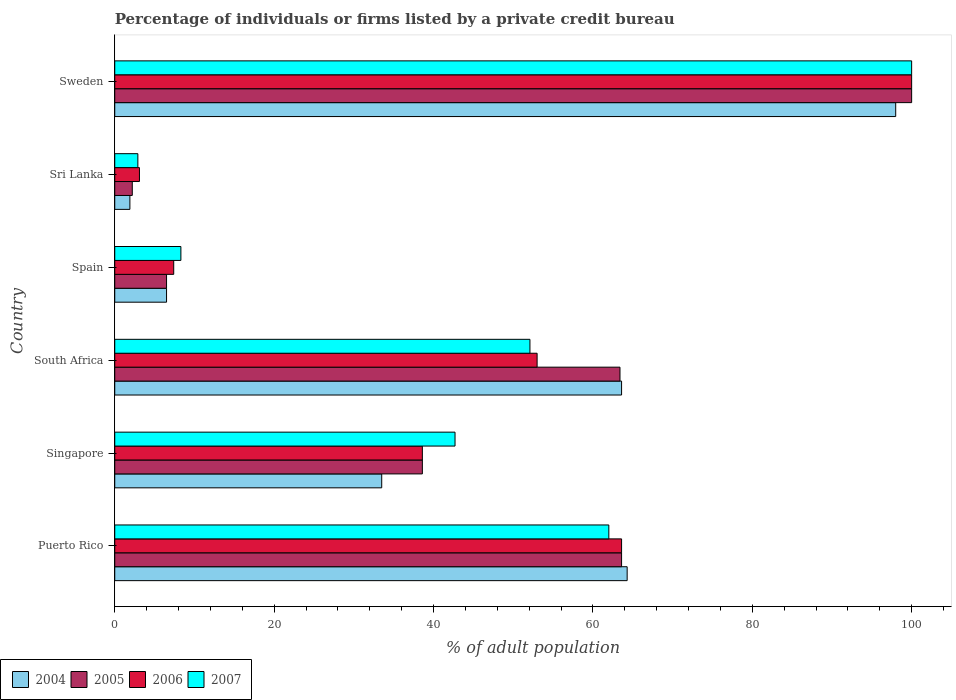Are the number of bars per tick equal to the number of legend labels?
Keep it short and to the point. Yes. Are the number of bars on each tick of the Y-axis equal?
Provide a short and direct response. Yes. What is the label of the 6th group of bars from the top?
Provide a short and direct response. Puerto Rico. In how many cases, is the number of bars for a given country not equal to the number of legend labels?
Ensure brevity in your answer.  0. What is the percentage of population listed by a private credit bureau in 2004 in Spain?
Your answer should be very brief. 6.5. Across all countries, what is the maximum percentage of population listed by a private credit bureau in 2004?
Your response must be concise. 98. Across all countries, what is the minimum percentage of population listed by a private credit bureau in 2007?
Provide a succinct answer. 2.9. In which country was the percentage of population listed by a private credit bureau in 2007 maximum?
Your response must be concise. Sweden. In which country was the percentage of population listed by a private credit bureau in 2004 minimum?
Provide a succinct answer. Sri Lanka. What is the total percentage of population listed by a private credit bureau in 2005 in the graph?
Make the answer very short. 274.3. What is the difference between the percentage of population listed by a private credit bureau in 2005 in South Africa and that in Sweden?
Your response must be concise. -36.6. What is the difference between the percentage of population listed by a private credit bureau in 2004 in Sweden and the percentage of population listed by a private credit bureau in 2006 in Spain?
Provide a succinct answer. 90.6. What is the average percentage of population listed by a private credit bureau in 2006 per country?
Keep it short and to the point. 44.28. What is the difference between the percentage of population listed by a private credit bureau in 2004 and percentage of population listed by a private credit bureau in 2006 in Singapore?
Give a very brief answer. -5.1. What is the ratio of the percentage of population listed by a private credit bureau in 2004 in South Africa to that in Sri Lanka?
Your answer should be compact. 33.47. What is the difference between the highest and the second highest percentage of population listed by a private credit bureau in 2006?
Make the answer very short. 36.4. What is the difference between the highest and the lowest percentage of population listed by a private credit bureau in 2004?
Ensure brevity in your answer.  96.1. In how many countries, is the percentage of population listed by a private credit bureau in 2005 greater than the average percentage of population listed by a private credit bureau in 2005 taken over all countries?
Make the answer very short. 3. Is the sum of the percentage of population listed by a private credit bureau in 2005 in Singapore and Sri Lanka greater than the maximum percentage of population listed by a private credit bureau in 2004 across all countries?
Make the answer very short. No. Is it the case that in every country, the sum of the percentage of population listed by a private credit bureau in 2006 and percentage of population listed by a private credit bureau in 2007 is greater than the sum of percentage of population listed by a private credit bureau in 2004 and percentage of population listed by a private credit bureau in 2005?
Your response must be concise. No. What does the 2nd bar from the top in Sri Lanka represents?
Give a very brief answer. 2006. How many bars are there?
Your answer should be compact. 24. Are all the bars in the graph horizontal?
Your response must be concise. Yes. Are the values on the major ticks of X-axis written in scientific E-notation?
Provide a short and direct response. No. Does the graph contain grids?
Keep it short and to the point. No. Where does the legend appear in the graph?
Offer a very short reply. Bottom left. How many legend labels are there?
Provide a short and direct response. 4. How are the legend labels stacked?
Provide a short and direct response. Horizontal. What is the title of the graph?
Provide a short and direct response. Percentage of individuals or firms listed by a private credit bureau. What is the label or title of the X-axis?
Offer a terse response. % of adult population. What is the label or title of the Y-axis?
Keep it short and to the point. Country. What is the % of adult population in 2004 in Puerto Rico?
Provide a succinct answer. 64.3. What is the % of adult population in 2005 in Puerto Rico?
Your answer should be very brief. 63.6. What is the % of adult population in 2006 in Puerto Rico?
Your response must be concise. 63.6. What is the % of adult population in 2007 in Puerto Rico?
Provide a succinct answer. 62. What is the % of adult population of 2004 in Singapore?
Ensure brevity in your answer.  33.5. What is the % of adult population in 2005 in Singapore?
Your answer should be compact. 38.6. What is the % of adult population of 2006 in Singapore?
Make the answer very short. 38.6. What is the % of adult population in 2007 in Singapore?
Ensure brevity in your answer.  42.7. What is the % of adult population of 2004 in South Africa?
Your answer should be very brief. 63.6. What is the % of adult population in 2005 in South Africa?
Offer a very short reply. 63.4. What is the % of adult population of 2006 in South Africa?
Offer a very short reply. 53. What is the % of adult population in 2007 in South Africa?
Offer a terse response. 52.1. What is the % of adult population in 2004 in Spain?
Make the answer very short. 6.5. What is the % of adult population in 2005 in Spain?
Your answer should be compact. 6.5. What is the % of adult population in 2007 in Spain?
Provide a succinct answer. 8.3. What is the % of adult population of 2004 in Sri Lanka?
Make the answer very short. 1.9. What is the % of adult population of 2006 in Sri Lanka?
Your response must be concise. 3.1. What is the % of adult population in 2007 in Sri Lanka?
Your answer should be compact. 2.9. What is the % of adult population of 2005 in Sweden?
Provide a short and direct response. 100. What is the % of adult population in 2006 in Sweden?
Give a very brief answer. 100. Across all countries, what is the maximum % of adult population in 2005?
Provide a succinct answer. 100. Across all countries, what is the maximum % of adult population of 2006?
Offer a very short reply. 100. Across all countries, what is the maximum % of adult population of 2007?
Provide a short and direct response. 100. Across all countries, what is the minimum % of adult population of 2004?
Your answer should be compact. 1.9. What is the total % of adult population in 2004 in the graph?
Keep it short and to the point. 267.8. What is the total % of adult population of 2005 in the graph?
Give a very brief answer. 274.3. What is the total % of adult population of 2006 in the graph?
Your answer should be very brief. 265.7. What is the total % of adult population in 2007 in the graph?
Your response must be concise. 268. What is the difference between the % of adult population of 2004 in Puerto Rico and that in Singapore?
Give a very brief answer. 30.8. What is the difference between the % of adult population of 2007 in Puerto Rico and that in Singapore?
Provide a succinct answer. 19.3. What is the difference between the % of adult population of 2004 in Puerto Rico and that in South Africa?
Provide a short and direct response. 0.7. What is the difference between the % of adult population in 2005 in Puerto Rico and that in South Africa?
Your response must be concise. 0.2. What is the difference between the % of adult population of 2006 in Puerto Rico and that in South Africa?
Provide a short and direct response. 10.6. What is the difference between the % of adult population in 2004 in Puerto Rico and that in Spain?
Ensure brevity in your answer.  57.8. What is the difference between the % of adult population of 2005 in Puerto Rico and that in Spain?
Make the answer very short. 57.1. What is the difference between the % of adult population of 2006 in Puerto Rico and that in Spain?
Provide a short and direct response. 56.2. What is the difference between the % of adult population of 2007 in Puerto Rico and that in Spain?
Give a very brief answer. 53.7. What is the difference between the % of adult population in 2004 in Puerto Rico and that in Sri Lanka?
Ensure brevity in your answer.  62.4. What is the difference between the % of adult population in 2005 in Puerto Rico and that in Sri Lanka?
Your response must be concise. 61.4. What is the difference between the % of adult population in 2006 in Puerto Rico and that in Sri Lanka?
Give a very brief answer. 60.5. What is the difference between the % of adult population in 2007 in Puerto Rico and that in Sri Lanka?
Provide a succinct answer. 59.1. What is the difference between the % of adult population in 2004 in Puerto Rico and that in Sweden?
Keep it short and to the point. -33.7. What is the difference between the % of adult population in 2005 in Puerto Rico and that in Sweden?
Keep it short and to the point. -36.4. What is the difference between the % of adult population of 2006 in Puerto Rico and that in Sweden?
Give a very brief answer. -36.4. What is the difference between the % of adult population of 2007 in Puerto Rico and that in Sweden?
Make the answer very short. -38. What is the difference between the % of adult population of 2004 in Singapore and that in South Africa?
Make the answer very short. -30.1. What is the difference between the % of adult population in 2005 in Singapore and that in South Africa?
Offer a very short reply. -24.8. What is the difference between the % of adult population in 2006 in Singapore and that in South Africa?
Your answer should be very brief. -14.4. What is the difference between the % of adult population in 2007 in Singapore and that in South Africa?
Give a very brief answer. -9.4. What is the difference between the % of adult population in 2005 in Singapore and that in Spain?
Your answer should be very brief. 32.1. What is the difference between the % of adult population in 2006 in Singapore and that in Spain?
Your response must be concise. 31.2. What is the difference between the % of adult population in 2007 in Singapore and that in Spain?
Offer a terse response. 34.4. What is the difference between the % of adult population in 2004 in Singapore and that in Sri Lanka?
Give a very brief answer. 31.6. What is the difference between the % of adult population of 2005 in Singapore and that in Sri Lanka?
Your answer should be very brief. 36.4. What is the difference between the % of adult population of 2006 in Singapore and that in Sri Lanka?
Provide a short and direct response. 35.5. What is the difference between the % of adult population of 2007 in Singapore and that in Sri Lanka?
Your response must be concise. 39.8. What is the difference between the % of adult population of 2004 in Singapore and that in Sweden?
Give a very brief answer. -64.5. What is the difference between the % of adult population of 2005 in Singapore and that in Sweden?
Provide a short and direct response. -61.4. What is the difference between the % of adult population in 2006 in Singapore and that in Sweden?
Your answer should be compact. -61.4. What is the difference between the % of adult population in 2007 in Singapore and that in Sweden?
Your answer should be compact. -57.3. What is the difference between the % of adult population of 2004 in South Africa and that in Spain?
Your response must be concise. 57.1. What is the difference between the % of adult population of 2005 in South Africa and that in Spain?
Ensure brevity in your answer.  56.9. What is the difference between the % of adult population in 2006 in South Africa and that in Spain?
Your answer should be compact. 45.6. What is the difference between the % of adult population of 2007 in South Africa and that in Spain?
Your response must be concise. 43.8. What is the difference between the % of adult population in 2004 in South Africa and that in Sri Lanka?
Offer a very short reply. 61.7. What is the difference between the % of adult population of 2005 in South Africa and that in Sri Lanka?
Offer a terse response. 61.2. What is the difference between the % of adult population in 2006 in South Africa and that in Sri Lanka?
Your answer should be compact. 49.9. What is the difference between the % of adult population of 2007 in South Africa and that in Sri Lanka?
Provide a short and direct response. 49.2. What is the difference between the % of adult population of 2004 in South Africa and that in Sweden?
Your answer should be very brief. -34.4. What is the difference between the % of adult population of 2005 in South Africa and that in Sweden?
Keep it short and to the point. -36.6. What is the difference between the % of adult population of 2006 in South Africa and that in Sweden?
Provide a short and direct response. -47. What is the difference between the % of adult population in 2007 in South Africa and that in Sweden?
Keep it short and to the point. -47.9. What is the difference between the % of adult population in 2004 in Spain and that in Sri Lanka?
Provide a short and direct response. 4.6. What is the difference between the % of adult population of 2005 in Spain and that in Sri Lanka?
Provide a succinct answer. 4.3. What is the difference between the % of adult population in 2007 in Spain and that in Sri Lanka?
Offer a very short reply. 5.4. What is the difference between the % of adult population in 2004 in Spain and that in Sweden?
Make the answer very short. -91.5. What is the difference between the % of adult population of 2005 in Spain and that in Sweden?
Offer a very short reply. -93.5. What is the difference between the % of adult population in 2006 in Spain and that in Sweden?
Make the answer very short. -92.6. What is the difference between the % of adult population in 2007 in Spain and that in Sweden?
Make the answer very short. -91.7. What is the difference between the % of adult population in 2004 in Sri Lanka and that in Sweden?
Provide a short and direct response. -96.1. What is the difference between the % of adult population in 2005 in Sri Lanka and that in Sweden?
Ensure brevity in your answer.  -97.8. What is the difference between the % of adult population of 2006 in Sri Lanka and that in Sweden?
Ensure brevity in your answer.  -96.9. What is the difference between the % of adult population of 2007 in Sri Lanka and that in Sweden?
Provide a succinct answer. -97.1. What is the difference between the % of adult population in 2004 in Puerto Rico and the % of adult population in 2005 in Singapore?
Keep it short and to the point. 25.7. What is the difference between the % of adult population of 2004 in Puerto Rico and the % of adult population of 2006 in Singapore?
Your answer should be compact. 25.7. What is the difference between the % of adult population of 2004 in Puerto Rico and the % of adult population of 2007 in Singapore?
Offer a terse response. 21.6. What is the difference between the % of adult population of 2005 in Puerto Rico and the % of adult population of 2007 in Singapore?
Provide a succinct answer. 20.9. What is the difference between the % of adult population of 2006 in Puerto Rico and the % of adult population of 2007 in Singapore?
Provide a short and direct response. 20.9. What is the difference between the % of adult population in 2004 in Puerto Rico and the % of adult population in 2006 in South Africa?
Give a very brief answer. 11.3. What is the difference between the % of adult population in 2005 in Puerto Rico and the % of adult population in 2006 in South Africa?
Provide a short and direct response. 10.6. What is the difference between the % of adult population of 2005 in Puerto Rico and the % of adult population of 2007 in South Africa?
Keep it short and to the point. 11.5. What is the difference between the % of adult population in 2004 in Puerto Rico and the % of adult population in 2005 in Spain?
Your answer should be compact. 57.8. What is the difference between the % of adult population of 2004 in Puerto Rico and the % of adult population of 2006 in Spain?
Offer a very short reply. 56.9. What is the difference between the % of adult population in 2005 in Puerto Rico and the % of adult population in 2006 in Spain?
Provide a short and direct response. 56.2. What is the difference between the % of adult population in 2005 in Puerto Rico and the % of adult population in 2007 in Spain?
Give a very brief answer. 55.3. What is the difference between the % of adult population in 2006 in Puerto Rico and the % of adult population in 2007 in Spain?
Provide a succinct answer. 55.3. What is the difference between the % of adult population of 2004 in Puerto Rico and the % of adult population of 2005 in Sri Lanka?
Your answer should be compact. 62.1. What is the difference between the % of adult population in 2004 in Puerto Rico and the % of adult population in 2006 in Sri Lanka?
Your answer should be compact. 61.2. What is the difference between the % of adult population of 2004 in Puerto Rico and the % of adult population of 2007 in Sri Lanka?
Offer a very short reply. 61.4. What is the difference between the % of adult population in 2005 in Puerto Rico and the % of adult population in 2006 in Sri Lanka?
Offer a very short reply. 60.5. What is the difference between the % of adult population of 2005 in Puerto Rico and the % of adult population of 2007 in Sri Lanka?
Provide a succinct answer. 60.7. What is the difference between the % of adult population of 2006 in Puerto Rico and the % of adult population of 2007 in Sri Lanka?
Provide a short and direct response. 60.7. What is the difference between the % of adult population in 2004 in Puerto Rico and the % of adult population in 2005 in Sweden?
Your answer should be compact. -35.7. What is the difference between the % of adult population of 2004 in Puerto Rico and the % of adult population of 2006 in Sweden?
Keep it short and to the point. -35.7. What is the difference between the % of adult population of 2004 in Puerto Rico and the % of adult population of 2007 in Sweden?
Give a very brief answer. -35.7. What is the difference between the % of adult population in 2005 in Puerto Rico and the % of adult population in 2006 in Sweden?
Offer a very short reply. -36.4. What is the difference between the % of adult population in 2005 in Puerto Rico and the % of adult population in 2007 in Sweden?
Give a very brief answer. -36.4. What is the difference between the % of adult population of 2006 in Puerto Rico and the % of adult population of 2007 in Sweden?
Your response must be concise. -36.4. What is the difference between the % of adult population in 2004 in Singapore and the % of adult population in 2005 in South Africa?
Provide a succinct answer. -29.9. What is the difference between the % of adult population in 2004 in Singapore and the % of adult population in 2006 in South Africa?
Your answer should be compact. -19.5. What is the difference between the % of adult population of 2004 in Singapore and the % of adult population of 2007 in South Africa?
Your answer should be very brief. -18.6. What is the difference between the % of adult population in 2005 in Singapore and the % of adult population in 2006 in South Africa?
Your answer should be compact. -14.4. What is the difference between the % of adult population of 2004 in Singapore and the % of adult population of 2005 in Spain?
Keep it short and to the point. 27. What is the difference between the % of adult population in 2004 in Singapore and the % of adult population in 2006 in Spain?
Provide a succinct answer. 26.1. What is the difference between the % of adult population of 2004 in Singapore and the % of adult population of 2007 in Spain?
Your response must be concise. 25.2. What is the difference between the % of adult population in 2005 in Singapore and the % of adult population in 2006 in Spain?
Offer a terse response. 31.2. What is the difference between the % of adult population in 2005 in Singapore and the % of adult population in 2007 in Spain?
Ensure brevity in your answer.  30.3. What is the difference between the % of adult population of 2006 in Singapore and the % of adult population of 2007 in Spain?
Your answer should be compact. 30.3. What is the difference between the % of adult population of 2004 in Singapore and the % of adult population of 2005 in Sri Lanka?
Keep it short and to the point. 31.3. What is the difference between the % of adult population of 2004 in Singapore and the % of adult population of 2006 in Sri Lanka?
Provide a short and direct response. 30.4. What is the difference between the % of adult population in 2004 in Singapore and the % of adult population in 2007 in Sri Lanka?
Your answer should be compact. 30.6. What is the difference between the % of adult population of 2005 in Singapore and the % of adult population of 2006 in Sri Lanka?
Your response must be concise. 35.5. What is the difference between the % of adult population of 2005 in Singapore and the % of adult population of 2007 in Sri Lanka?
Make the answer very short. 35.7. What is the difference between the % of adult population in 2006 in Singapore and the % of adult population in 2007 in Sri Lanka?
Make the answer very short. 35.7. What is the difference between the % of adult population of 2004 in Singapore and the % of adult population of 2005 in Sweden?
Offer a terse response. -66.5. What is the difference between the % of adult population of 2004 in Singapore and the % of adult population of 2006 in Sweden?
Give a very brief answer. -66.5. What is the difference between the % of adult population in 2004 in Singapore and the % of adult population in 2007 in Sweden?
Keep it short and to the point. -66.5. What is the difference between the % of adult population in 2005 in Singapore and the % of adult population in 2006 in Sweden?
Make the answer very short. -61.4. What is the difference between the % of adult population in 2005 in Singapore and the % of adult population in 2007 in Sweden?
Your answer should be very brief. -61.4. What is the difference between the % of adult population in 2006 in Singapore and the % of adult population in 2007 in Sweden?
Give a very brief answer. -61.4. What is the difference between the % of adult population in 2004 in South Africa and the % of adult population in 2005 in Spain?
Provide a succinct answer. 57.1. What is the difference between the % of adult population of 2004 in South Africa and the % of adult population of 2006 in Spain?
Ensure brevity in your answer.  56.2. What is the difference between the % of adult population in 2004 in South Africa and the % of adult population in 2007 in Spain?
Ensure brevity in your answer.  55.3. What is the difference between the % of adult population of 2005 in South Africa and the % of adult population of 2006 in Spain?
Your answer should be very brief. 56. What is the difference between the % of adult population in 2005 in South Africa and the % of adult population in 2007 in Spain?
Ensure brevity in your answer.  55.1. What is the difference between the % of adult population in 2006 in South Africa and the % of adult population in 2007 in Spain?
Keep it short and to the point. 44.7. What is the difference between the % of adult population in 2004 in South Africa and the % of adult population in 2005 in Sri Lanka?
Make the answer very short. 61.4. What is the difference between the % of adult population in 2004 in South Africa and the % of adult population in 2006 in Sri Lanka?
Your answer should be very brief. 60.5. What is the difference between the % of adult population of 2004 in South Africa and the % of adult population of 2007 in Sri Lanka?
Your answer should be very brief. 60.7. What is the difference between the % of adult population of 2005 in South Africa and the % of adult population of 2006 in Sri Lanka?
Your answer should be very brief. 60.3. What is the difference between the % of adult population in 2005 in South Africa and the % of adult population in 2007 in Sri Lanka?
Give a very brief answer. 60.5. What is the difference between the % of adult population of 2006 in South Africa and the % of adult population of 2007 in Sri Lanka?
Your answer should be compact. 50.1. What is the difference between the % of adult population in 2004 in South Africa and the % of adult population in 2005 in Sweden?
Give a very brief answer. -36.4. What is the difference between the % of adult population of 2004 in South Africa and the % of adult population of 2006 in Sweden?
Your answer should be very brief. -36.4. What is the difference between the % of adult population of 2004 in South Africa and the % of adult population of 2007 in Sweden?
Keep it short and to the point. -36.4. What is the difference between the % of adult population in 2005 in South Africa and the % of adult population in 2006 in Sweden?
Provide a short and direct response. -36.6. What is the difference between the % of adult population in 2005 in South Africa and the % of adult population in 2007 in Sweden?
Your answer should be very brief. -36.6. What is the difference between the % of adult population in 2006 in South Africa and the % of adult population in 2007 in Sweden?
Provide a succinct answer. -47. What is the difference between the % of adult population of 2004 in Spain and the % of adult population of 2007 in Sri Lanka?
Offer a very short reply. 3.6. What is the difference between the % of adult population of 2005 in Spain and the % of adult population of 2007 in Sri Lanka?
Your response must be concise. 3.6. What is the difference between the % of adult population of 2006 in Spain and the % of adult population of 2007 in Sri Lanka?
Provide a short and direct response. 4.5. What is the difference between the % of adult population in 2004 in Spain and the % of adult population in 2005 in Sweden?
Your answer should be compact. -93.5. What is the difference between the % of adult population of 2004 in Spain and the % of adult population of 2006 in Sweden?
Provide a succinct answer. -93.5. What is the difference between the % of adult population in 2004 in Spain and the % of adult population in 2007 in Sweden?
Your answer should be compact. -93.5. What is the difference between the % of adult population in 2005 in Spain and the % of adult population in 2006 in Sweden?
Provide a short and direct response. -93.5. What is the difference between the % of adult population of 2005 in Spain and the % of adult population of 2007 in Sweden?
Provide a short and direct response. -93.5. What is the difference between the % of adult population in 2006 in Spain and the % of adult population in 2007 in Sweden?
Your answer should be compact. -92.6. What is the difference between the % of adult population of 2004 in Sri Lanka and the % of adult population of 2005 in Sweden?
Offer a very short reply. -98.1. What is the difference between the % of adult population of 2004 in Sri Lanka and the % of adult population of 2006 in Sweden?
Keep it short and to the point. -98.1. What is the difference between the % of adult population in 2004 in Sri Lanka and the % of adult population in 2007 in Sweden?
Offer a very short reply. -98.1. What is the difference between the % of adult population in 2005 in Sri Lanka and the % of adult population in 2006 in Sweden?
Offer a terse response. -97.8. What is the difference between the % of adult population in 2005 in Sri Lanka and the % of adult population in 2007 in Sweden?
Offer a terse response. -97.8. What is the difference between the % of adult population of 2006 in Sri Lanka and the % of adult population of 2007 in Sweden?
Make the answer very short. -96.9. What is the average % of adult population in 2004 per country?
Give a very brief answer. 44.63. What is the average % of adult population of 2005 per country?
Make the answer very short. 45.72. What is the average % of adult population of 2006 per country?
Ensure brevity in your answer.  44.28. What is the average % of adult population of 2007 per country?
Your answer should be very brief. 44.67. What is the difference between the % of adult population of 2004 and % of adult population of 2005 in Puerto Rico?
Make the answer very short. 0.7. What is the difference between the % of adult population in 2004 and % of adult population in 2006 in Puerto Rico?
Offer a very short reply. 0.7. What is the difference between the % of adult population of 2004 and % of adult population of 2007 in Puerto Rico?
Your answer should be very brief. 2.3. What is the difference between the % of adult population of 2004 and % of adult population of 2005 in Singapore?
Provide a short and direct response. -5.1. What is the difference between the % of adult population in 2004 and % of adult population in 2006 in Singapore?
Ensure brevity in your answer.  -5.1. What is the difference between the % of adult population in 2005 and % of adult population in 2006 in Singapore?
Your answer should be compact. 0. What is the difference between the % of adult population of 2005 and % of adult population of 2007 in South Africa?
Offer a terse response. 11.3. What is the difference between the % of adult population in 2004 and % of adult population in 2005 in Spain?
Keep it short and to the point. 0. What is the difference between the % of adult population in 2004 and % of adult population in 2006 in Spain?
Your response must be concise. -0.9. What is the difference between the % of adult population in 2005 and % of adult population in 2007 in Spain?
Your response must be concise. -1.8. What is the difference between the % of adult population in 2004 and % of adult population in 2006 in Sri Lanka?
Ensure brevity in your answer.  -1.2. What is the difference between the % of adult population in 2004 and % of adult population in 2005 in Sweden?
Your answer should be compact. -2. What is the difference between the % of adult population of 2004 and % of adult population of 2007 in Sweden?
Give a very brief answer. -2. What is the difference between the % of adult population in 2005 and % of adult population in 2006 in Sweden?
Provide a short and direct response. 0. What is the difference between the % of adult population of 2006 and % of adult population of 2007 in Sweden?
Your response must be concise. 0. What is the ratio of the % of adult population in 2004 in Puerto Rico to that in Singapore?
Make the answer very short. 1.92. What is the ratio of the % of adult population of 2005 in Puerto Rico to that in Singapore?
Make the answer very short. 1.65. What is the ratio of the % of adult population of 2006 in Puerto Rico to that in Singapore?
Your response must be concise. 1.65. What is the ratio of the % of adult population in 2007 in Puerto Rico to that in Singapore?
Provide a succinct answer. 1.45. What is the ratio of the % of adult population in 2005 in Puerto Rico to that in South Africa?
Your response must be concise. 1. What is the ratio of the % of adult population in 2006 in Puerto Rico to that in South Africa?
Give a very brief answer. 1.2. What is the ratio of the % of adult population in 2007 in Puerto Rico to that in South Africa?
Provide a short and direct response. 1.19. What is the ratio of the % of adult population of 2004 in Puerto Rico to that in Spain?
Offer a terse response. 9.89. What is the ratio of the % of adult population of 2005 in Puerto Rico to that in Spain?
Keep it short and to the point. 9.78. What is the ratio of the % of adult population of 2006 in Puerto Rico to that in Spain?
Give a very brief answer. 8.59. What is the ratio of the % of adult population of 2007 in Puerto Rico to that in Spain?
Offer a terse response. 7.47. What is the ratio of the % of adult population of 2004 in Puerto Rico to that in Sri Lanka?
Provide a short and direct response. 33.84. What is the ratio of the % of adult population of 2005 in Puerto Rico to that in Sri Lanka?
Your answer should be compact. 28.91. What is the ratio of the % of adult population of 2006 in Puerto Rico to that in Sri Lanka?
Your answer should be compact. 20.52. What is the ratio of the % of adult population of 2007 in Puerto Rico to that in Sri Lanka?
Give a very brief answer. 21.38. What is the ratio of the % of adult population of 2004 in Puerto Rico to that in Sweden?
Your answer should be compact. 0.66. What is the ratio of the % of adult population of 2005 in Puerto Rico to that in Sweden?
Your response must be concise. 0.64. What is the ratio of the % of adult population in 2006 in Puerto Rico to that in Sweden?
Offer a very short reply. 0.64. What is the ratio of the % of adult population of 2007 in Puerto Rico to that in Sweden?
Provide a succinct answer. 0.62. What is the ratio of the % of adult population of 2004 in Singapore to that in South Africa?
Keep it short and to the point. 0.53. What is the ratio of the % of adult population of 2005 in Singapore to that in South Africa?
Make the answer very short. 0.61. What is the ratio of the % of adult population in 2006 in Singapore to that in South Africa?
Your answer should be very brief. 0.73. What is the ratio of the % of adult population in 2007 in Singapore to that in South Africa?
Offer a very short reply. 0.82. What is the ratio of the % of adult population in 2004 in Singapore to that in Spain?
Your answer should be compact. 5.15. What is the ratio of the % of adult population of 2005 in Singapore to that in Spain?
Give a very brief answer. 5.94. What is the ratio of the % of adult population of 2006 in Singapore to that in Spain?
Your answer should be very brief. 5.22. What is the ratio of the % of adult population of 2007 in Singapore to that in Spain?
Give a very brief answer. 5.14. What is the ratio of the % of adult population of 2004 in Singapore to that in Sri Lanka?
Your answer should be very brief. 17.63. What is the ratio of the % of adult population of 2005 in Singapore to that in Sri Lanka?
Offer a very short reply. 17.55. What is the ratio of the % of adult population in 2006 in Singapore to that in Sri Lanka?
Offer a terse response. 12.45. What is the ratio of the % of adult population in 2007 in Singapore to that in Sri Lanka?
Your answer should be very brief. 14.72. What is the ratio of the % of adult population of 2004 in Singapore to that in Sweden?
Your answer should be compact. 0.34. What is the ratio of the % of adult population of 2005 in Singapore to that in Sweden?
Give a very brief answer. 0.39. What is the ratio of the % of adult population of 2006 in Singapore to that in Sweden?
Offer a terse response. 0.39. What is the ratio of the % of adult population in 2007 in Singapore to that in Sweden?
Offer a very short reply. 0.43. What is the ratio of the % of adult population of 2004 in South Africa to that in Spain?
Provide a short and direct response. 9.78. What is the ratio of the % of adult population in 2005 in South Africa to that in Spain?
Offer a terse response. 9.75. What is the ratio of the % of adult population of 2006 in South Africa to that in Spain?
Offer a very short reply. 7.16. What is the ratio of the % of adult population in 2007 in South Africa to that in Spain?
Ensure brevity in your answer.  6.28. What is the ratio of the % of adult population of 2004 in South Africa to that in Sri Lanka?
Provide a short and direct response. 33.47. What is the ratio of the % of adult population of 2005 in South Africa to that in Sri Lanka?
Offer a very short reply. 28.82. What is the ratio of the % of adult population of 2006 in South Africa to that in Sri Lanka?
Give a very brief answer. 17.1. What is the ratio of the % of adult population of 2007 in South Africa to that in Sri Lanka?
Provide a succinct answer. 17.97. What is the ratio of the % of adult population in 2004 in South Africa to that in Sweden?
Ensure brevity in your answer.  0.65. What is the ratio of the % of adult population in 2005 in South Africa to that in Sweden?
Your answer should be very brief. 0.63. What is the ratio of the % of adult population of 2006 in South Africa to that in Sweden?
Provide a succinct answer. 0.53. What is the ratio of the % of adult population of 2007 in South Africa to that in Sweden?
Offer a terse response. 0.52. What is the ratio of the % of adult population of 2004 in Spain to that in Sri Lanka?
Your response must be concise. 3.42. What is the ratio of the % of adult population in 2005 in Spain to that in Sri Lanka?
Your response must be concise. 2.95. What is the ratio of the % of adult population of 2006 in Spain to that in Sri Lanka?
Make the answer very short. 2.39. What is the ratio of the % of adult population in 2007 in Spain to that in Sri Lanka?
Your answer should be compact. 2.86. What is the ratio of the % of adult population in 2004 in Spain to that in Sweden?
Your answer should be compact. 0.07. What is the ratio of the % of adult population in 2005 in Spain to that in Sweden?
Keep it short and to the point. 0.07. What is the ratio of the % of adult population of 2006 in Spain to that in Sweden?
Your answer should be compact. 0.07. What is the ratio of the % of adult population in 2007 in Spain to that in Sweden?
Make the answer very short. 0.08. What is the ratio of the % of adult population in 2004 in Sri Lanka to that in Sweden?
Provide a succinct answer. 0.02. What is the ratio of the % of adult population of 2005 in Sri Lanka to that in Sweden?
Your answer should be compact. 0.02. What is the ratio of the % of adult population of 2006 in Sri Lanka to that in Sweden?
Offer a terse response. 0.03. What is the ratio of the % of adult population of 2007 in Sri Lanka to that in Sweden?
Provide a succinct answer. 0.03. What is the difference between the highest and the second highest % of adult population in 2004?
Provide a short and direct response. 33.7. What is the difference between the highest and the second highest % of adult population in 2005?
Provide a succinct answer. 36.4. What is the difference between the highest and the second highest % of adult population of 2006?
Offer a terse response. 36.4. What is the difference between the highest and the second highest % of adult population of 2007?
Your answer should be very brief. 38. What is the difference between the highest and the lowest % of adult population in 2004?
Provide a succinct answer. 96.1. What is the difference between the highest and the lowest % of adult population in 2005?
Offer a very short reply. 97.8. What is the difference between the highest and the lowest % of adult population in 2006?
Your answer should be compact. 96.9. What is the difference between the highest and the lowest % of adult population of 2007?
Your response must be concise. 97.1. 